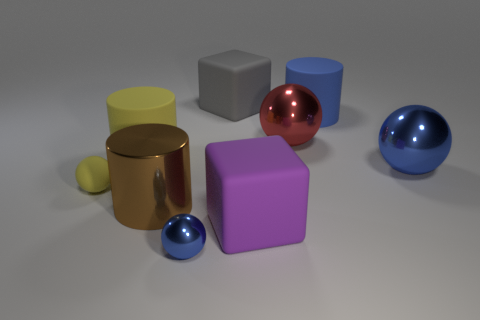Subtract all big blue shiny spheres. How many spheres are left? 3 Subtract all big gray rubber blocks. Subtract all rubber balls. How many objects are left? 7 Add 6 small yellow matte spheres. How many small yellow matte spheres are left? 7 Add 1 red objects. How many red objects exist? 2 Add 1 large brown rubber things. How many objects exist? 10 Subtract all red balls. How many balls are left? 3 Subtract 0 green cylinders. How many objects are left? 9 Subtract all cubes. How many objects are left? 7 Subtract 1 cylinders. How many cylinders are left? 2 Subtract all red blocks. Subtract all blue cylinders. How many blocks are left? 2 